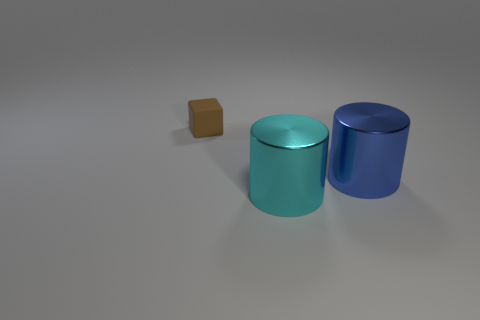Are there any other things that have the same size as the block?
Provide a short and direct response. No. Are any tiny red cubes visible?
Your answer should be very brief. No. There is a shiny cylinder in front of the blue cylinder; what color is it?
Your answer should be compact. Cyan. There is a blue thing; are there any tiny brown matte objects to the right of it?
Provide a succinct answer. No. Is the number of big red shiny cylinders greater than the number of tiny brown things?
Ensure brevity in your answer.  No. What is the color of the metallic object that is to the right of the big shiny cylinder that is in front of the metallic object right of the big cyan shiny cylinder?
Ensure brevity in your answer.  Blue. There is another object that is the same material as the large cyan thing; what is its color?
Your response must be concise. Blue. How many things are either objects right of the small brown matte block or objects that are in front of the tiny thing?
Provide a short and direct response. 2. Do the cylinder that is in front of the large blue object and the thing left of the big cyan cylinder have the same size?
Your answer should be very brief. No. There is another metal thing that is the same shape as the big cyan shiny object; what is its color?
Make the answer very short. Blue. 